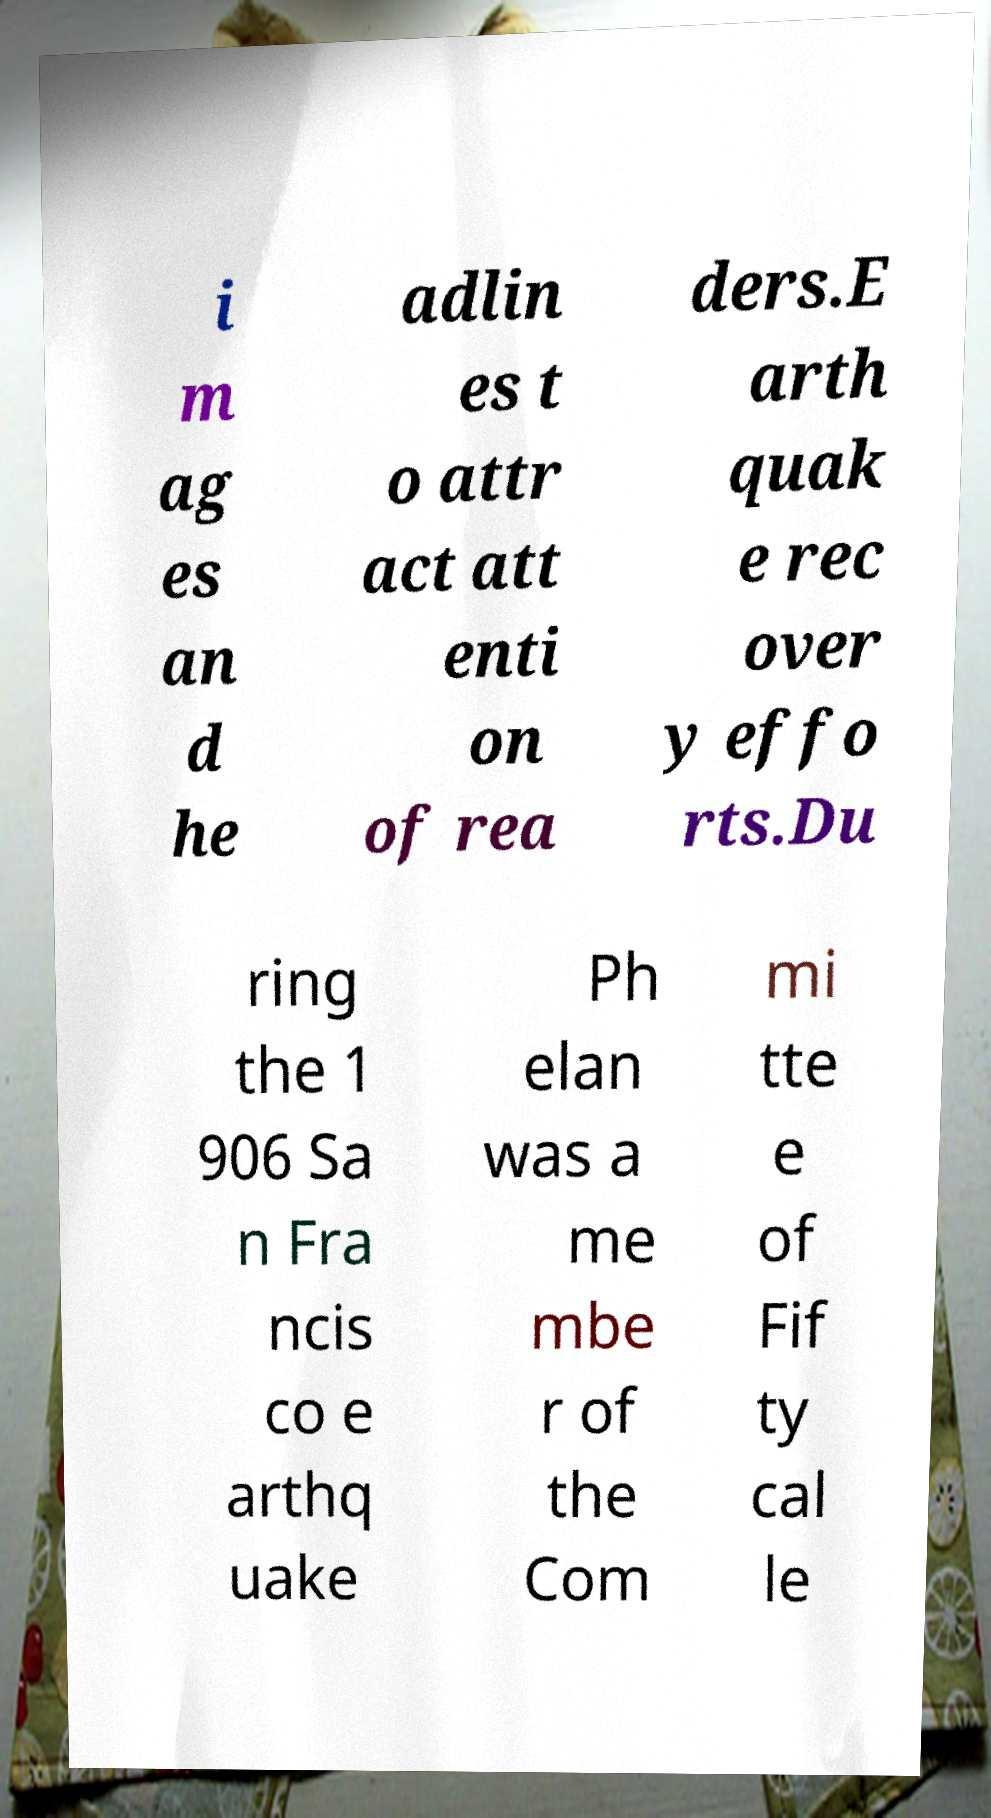What messages or text are displayed in this image? I need them in a readable, typed format. i m ag es an d he adlin es t o attr act att enti on of rea ders.E arth quak e rec over y effo rts.Du ring the 1 906 Sa n Fra ncis co e arthq uake Ph elan was a me mbe r of the Com mi tte e of Fif ty cal le 